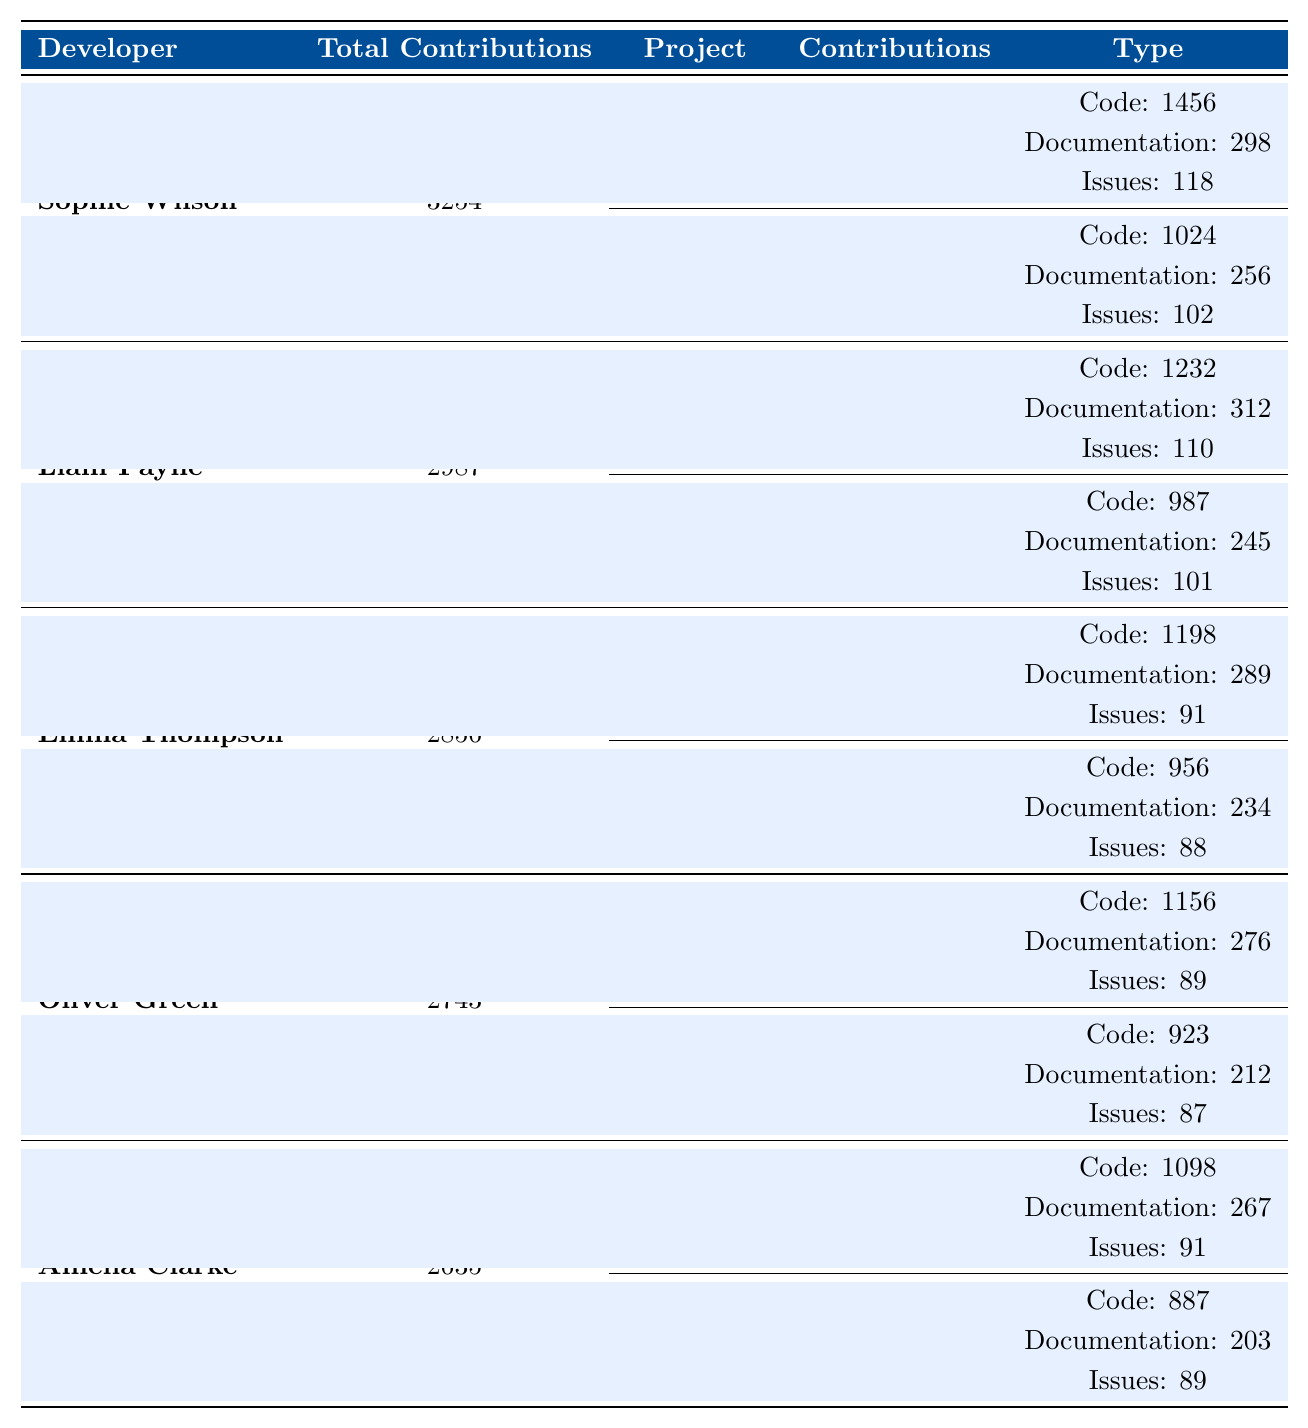What is the total number of contributions made by Sophie Wilson? The table shows that Sophie Wilson made a total of 3254 contributions, as indicated in the Total Contributions column.
Answer: 3254 Which project did Liam Payne contribute to the most? By looking at the Contributions for Liam Payne, React has the highest contributions at 1654 compared to Vue.js at 1333.
Answer: React How many contributions did Emma Thompson make to Flask? Emma Thompson's contributions to the Flask project are listed as 1278 in the Contributions column for that project.
Answer: 1278 What percentage of total contributions did Oliver Green make to Docker? To find the percentage, calculate (1222 / 2743) * 100 = approximately 44.5%. Therefore, Oliver's contributions to Docker represent around 44.5% of his total contributions.
Answer: 44.5% Who contributed more to their projects, Amelia Clarke or Harry Smith? Amelia Clarke’s total contributions are 2635, while Harry Smith made 2524 contributions. Since 2635 is greater than 2524, Amelia contributed more.
Answer: Amelia Clarke What is the sum of total contributions for all listed developers? To find the sum, add all totals: 3254 + 2987 + 2856 + 2743 + 2635 + 2524 + 2418 + 2312 + 2209 + 2107 = 29,725 contributions.
Answer: 29725 Did Isabella Brown contribute more to Rust or Go? The contributions for Isabella to Rust are 1329 and for Go are 1089. Since 1329 is greater than 1089, she contributed more to Rust.
Answer: Yes What is the average number of contributions per project for George Taylor? George Taylor has contributions from two projects: Ruby on Rails (1276) and Sinatra (1036). Thus, the average is (1276 + 1036) / 2 = 1156 contributions per project.
Answer: 1156 How many issues were reported by Liam Payne in React? The table indicates Liam Payne reported 110 issues in the React project under the Type column.
Answer: 110 Which developer has the highest total contributions? Sophie Wilson has the highest total contributions with 3254, compared to others who have fewer than that.
Answer: Sophie Wilson 